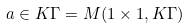Convert formula to latex. <formula><loc_0><loc_0><loc_500><loc_500>a \in K \Gamma = M ( 1 \times 1 , K \Gamma )</formula> 